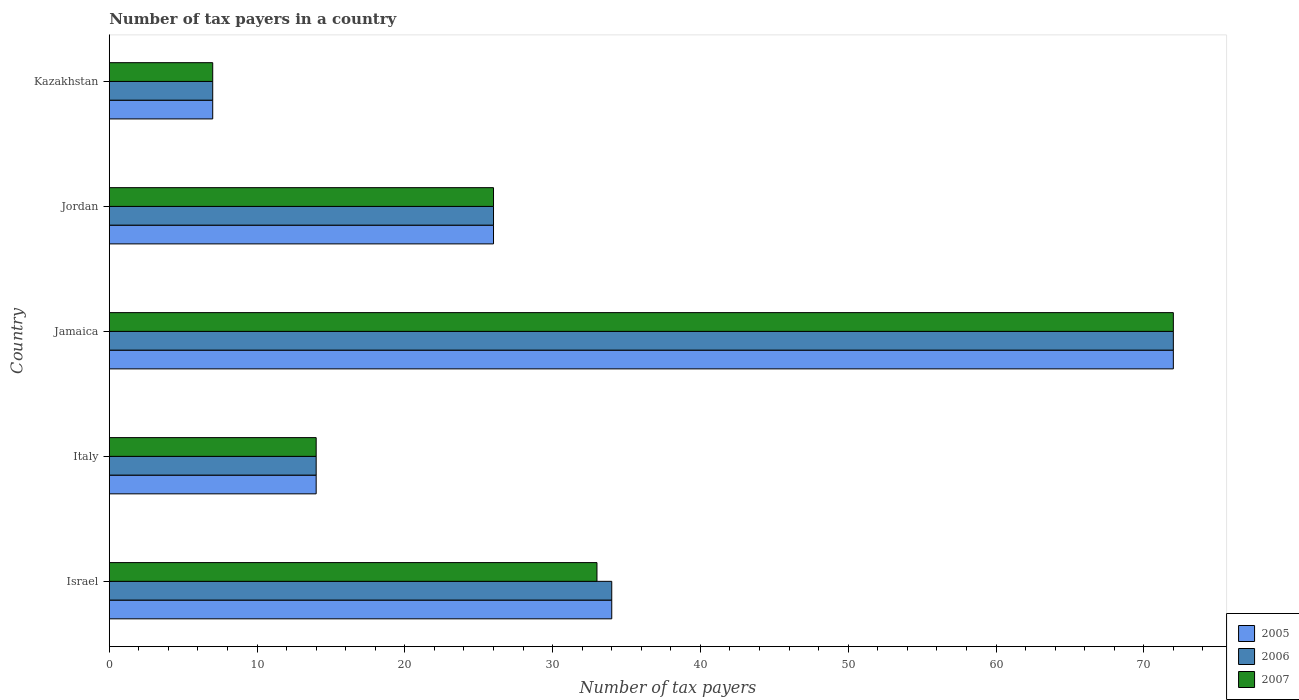Are the number of bars per tick equal to the number of legend labels?
Offer a very short reply. Yes. Are the number of bars on each tick of the Y-axis equal?
Your answer should be compact. Yes. How many bars are there on the 1st tick from the top?
Your answer should be very brief. 3. What is the label of the 2nd group of bars from the top?
Make the answer very short. Jordan. Across all countries, what is the maximum number of tax payers in in 2007?
Keep it short and to the point. 72. In which country was the number of tax payers in in 2006 maximum?
Keep it short and to the point. Jamaica. In which country was the number of tax payers in in 2007 minimum?
Ensure brevity in your answer.  Kazakhstan. What is the total number of tax payers in in 2006 in the graph?
Give a very brief answer. 153. What is the difference between the number of tax payers in in 2006 in Israel and that in Italy?
Your answer should be compact. 20. What is the difference between the number of tax payers in in 2007 in Jordan and the number of tax payers in in 2005 in Jamaica?
Your response must be concise. -46. What is the average number of tax payers in in 2006 per country?
Keep it short and to the point. 30.6. What is the ratio of the number of tax payers in in 2006 in Jamaica to that in Kazakhstan?
Your answer should be compact. 10.29. Is the number of tax payers in in 2005 in Jordan less than that in Kazakhstan?
Make the answer very short. No. What is the difference between the highest and the lowest number of tax payers in in 2006?
Provide a short and direct response. 65. In how many countries, is the number of tax payers in in 2005 greater than the average number of tax payers in in 2005 taken over all countries?
Offer a very short reply. 2. Are all the bars in the graph horizontal?
Offer a very short reply. Yes. How many countries are there in the graph?
Give a very brief answer. 5. Does the graph contain any zero values?
Your response must be concise. No. Does the graph contain grids?
Provide a short and direct response. No. Where does the legend appear in the graph?
Your answer should be very brief. Bottom right. How are the legend labels stacked?
Provide a short and direct response. Vertical. What is the title of the graph?
Ensure brevity in your answer.  Number of tax payers in a country. What is the label or title of the X-axis?
Offer a terse response. Number of tax payers. What is the label or title of the Y-axis?
Ensure brevity in your answer.  Country. What is the Number of tax payers in 2006 in Israel?
Your response must be concise. 34. What is the Number of tax payers in 2005 in Italy?
Your answer should be compact. 14. What is the Number of tax payers of 2006 in Italy?
Give a very brief answer. 14. What is the Number of tax payers in 2005 in Jamaica?
Offer a very short reply. 72. What is the Number of tax payers in 2006 in Jamaica?
Ensure brevity in your answer.  72. What is the Number of tax payers in 2007 in Jamaica?
Make the answer very short. 72. What is the Number of tax payers of 2006 in Jordan?
Make the answer very short. 26. What is the Number of tax payers in 2005 in Kazakhstan?
Your answer should be very brief. 7. What is the Number of tax payers in 2007 in Kazakhstan?
Ensure brevity in your answer.  7. Across all countries, what is the maximum Number of tax payers in 2005?
Ensure brevity in your answer.  72. Across all countries, what is the maximum Number of tax payers in 2006?
Your answer should be compact. 72. Across all countries, what is the minimum Number of tax payers in 2006?
Provide a short and direct response. 7. Across all countries, what is the minimum Number of tax payers in 2007?
Your response must be concise. 7. What is the total Number of tax payers of 2005 in the graph?
Give a very brief answer. 153. What is the total Number of tax payers of 2006 in the graph?
Provide a succinct answer. 153. What is the total Number of tax payers in 2007 in the graph?
Keep it short and to the point. 152. What is the difference between the Number of tax payers in 2005 in Israel and that in Italy?
Your answer should be compact. 20. What is the difference between the Number of tax payers in 2006 in Israel and that in Italy?
Provide a succinct answer. 20. What is the difference between the Number of tax payers in 2005 in Israel and that in Jamaica?
Keep it short and to the point. -38. What is the difference between the Number of tax payers in 2006 in Israel and that in Jamaica?
Offer a very short reply. -38. What is the difference between the Number of tax payers in 2007 in Israel and that in Jamaica?
Provide a short and direct response. -39. What is the difference between the Number of tax payers in 2005 in Israel and that in Jordan?
Your answer should be very brief. 8. What is the difference between the Number of tax payers of 2007 in Israel and that in Jordan?
Make the answer very short. 7. What is the difference between the Number of tax payers of 2005 in Israel and that in Kazakhstan?
Make the answer very short. 27. What is the difference between the Number of tax payers in 2006 in Israel and that in Kazakhstan?
Keep it short and to the point. 27. What is the difference between the Number of tax payers of 2005 in Italy and that in Jamaica?
Offer a terse response. -58. What is the difference between the Number of tax payers in 2006 in Italy and that in Jamaica?
Offer a terse response. -58. What is the difference between the Number of tax payers in 2007 in Italy and that in Jamaica?
Make the answer very short. -58. What is the difference between the Number of tax payers in 2005 in Italy and that in Jordan?
Offer a terse response. -12. What is the difference between the Number of tax payers of 2006 in Italy and that in Kazakhstan?
Make the answer very short. 7. What is the difference between the Number of tax payers of 2007 in Italy and that in Kazakhstan?
Offer a terse response. 7. What is the difference between the Number of tax payers in 2005 in Jamaica and that in Jordan?
Ensure brevity in your answer.  46. What is the difference between the Number of tax payers of 2007 in Jamaica and that in Jordan?
Ensure brevity in your answer.  46. What is the difference between the Number of tax payers in 2005 in Jamaica and that in Kazakhstan?
Your response must be concise. 65. What is the difference between the Number of tax payers of 2006 in Jamaica and that in Kazakhstan?
Provide a short and direct response. 65. What is the difference between the Number of tax payers in 2005 in Jordan and that in Kazakhstan?
Offer a terse response. 19. What is the difference between the Number of tax payers of 2006 in Jordan and that in Kazakhstan?
Give a very brief answer. 19. What is the difference between the Number of tax payers of 2005 in Israel and the Number of tax payers of 2006 in Jamaica?
Your answer should be very brief. -38. What is the difference between the Number of tax payers in 2005 in Israel and the Number of tax payers in 2007 in Jamaica?
Provide a short and direct response. -38. What is the difference between the Number of tax payers in 2006 in Israel and the Number of tax payers in 2007 in Jamaica?
Your answer should be compact. -38. What is the difference between the Number of tax payers in 2006 in Israel and the Number of tax payers in 2007 in Jordan?
Keep it short and to the point. 8. What is the difference between the Number of tax payers in 2005 in Israel and the Number of tax payers in 2006 in Kazakhstan?
Provide a short and direct response. 27. What is the difference between the Number of tax payers in 2006 in Israel and the Number of tax payers in 2007 in Kazakhstan?
Keep it short and to the point. 27. What is the difference between the Number of tax payers of 2005 in Italy and the Number of tax payers of 2006 in Jamaica?
Provide a short and direct response. -58. What is the difference between the Number of tax payers in 2005 in Italy and the Number of tax payers in 2007 in Jamaica?
Provide a short and direct response. -58. What is the difference between the Number of tax payers of 2006 in Italy and the Number of tax payers of 2007 in Jamaica?
Offer a very short reply. -58. What is the difference between the Number of tax payers of 2005 in Italy and the Number of tax payers of 2006 in Jordan?
Offer a very short reply. -12. What is the difference between the Number of tax payers of 2005 in Italy and the Number of tax payers of 2007 in Jordan?
Give a very brief answer. -12. What is the difference between the Number of tax payers of 2006 in Italy and the Number of tax payers of 2007 in Jordan?
Give a very brief answer. -12. What is the difference between the Number of tax payers in 2005 in Jamaica and the Number of tax payers in 2006 in Jordan?
Your answer should be compact. 46. What is the difference between the Number of tax payers of 2005 in Jamaica and the Number of tax payers of 2007 in Jordan?
Your answer should be compact. 46. What is the difference between the Number of tax payers of 2006 in Jamaica and the Number of tax payers of 2007 in Jordan?
Your response must be concise. 46. What is the difference between the Number of tax payers of 2005 in Jamaica and the Number of tax payers of 2006 in Kazakhstan?
Provide a succinct answer. 65. What is the difference between the Number of tax payers in 2005 in Jamaica and the Number of tax payers in 2007 in Kazakhstan?
Your response must be concise. 65. What is the difference between the Number of tax payers of 2005 in Jordan and the Number of tax payers of 2006 in Kazakhstan?
Your response must be concise. 19. What is the average Number of tax payers in 2005 per country?
Make the answer very short. 30.6. What is the average Number of tax payers of 2006 per country?
Keep it short and to the point. 30.6. What is the average Number of tax payers of 2007 per country?
Offer a terse response. 30.4. What is the difference between the Number of tax payers in 2005 and Number of tax payers in 2006 in Israel?
Provide a succinct answer. 0. What is the difference between the Number of tax payers in 2006 and Number of tax payers in 2007 in Israel?
Offer a very short reply. 1. What is the difference between the Number of tax payers in 2006 and Number of tax payers in 2007 in Italy?
Offer a terse response. 0. What is the difference between the Number of tax payers of 2005 and Number of tax payers of 2007 in Jamaica?
Provide a short and direct response. 0. What is the difference between the Number of tax payers of 2006 and Number of tax payers of 2007 in Jordan?
Your answer should be compact. 0. What is the ratio of the Number of tax payers in 2005 in Israel to that in Italy?
Give a very brief answer. 2.43. What is the ratio of the Number of tax payers of 2006 in Israel to that in Italy?
Provide a succinct answer. 2.43. What is the ratio of the Number of tax payers of 2007 in Israel to that in Italy?
Give a very brief answer. 2.36. What is the ratio of the Number of tax payers of 2005 in Israel to that in Jamaica?
Provide a short and direct response. 0.47. What is the ratio of the Number of tax payers of 2006 in Israel to that in Jamaica?
Offer a very short reply. 0.47. What is the ratio of the Number of tax payers in 2007 in Israel to that in Jamaica?
Keep it short and to the point. 0.46. What is the ratio of the Number of tax payers in 2005 in Israel to that in Jordan?
Your response must be concise. 1.31. What is the ratio of the Number of tax payers of 2006 in Israel to that in Jordan?
Offer a terse response. 1.31. What is the ratio of the Number of tax payers in 2007 in Israel to that in Jordan?
Offer a very short reply. 1.27. What is the ratio of the Number of tax payers of 2005 in Israel to that in Kazakhstan?
Your answer should be very brief. 4.86. What is the ratio of the Number of tax payers of 2006 in Israel to that in Kazakhstan?
Provide a short and direct response. 4.86. What is the ratio of the Number of tax payers of 2007 in Israel to that in Kazakhstan?
Keep it short and to the point. 4.71. What is the ratio of the Number of tax payers in 2005 in Italy to that in Jamaica?
Provide a succinct answer. 0.19. What is the ratio of the Number of tax payers in 2006 in Italy to that in Jamaica?
Provide a succinct answer. 0.19. What is the ratio of the Number of tax payers in 2007 in Italy to that in Jamaica?
Provide a succinct answer. 0.19. What is the ratio of the Number of tax payers of 2005 in Italy to that in Jordan?
Keep it short and to the point. 0.54. What is the ratio of the Number of tax payers in 2006 in Italy to that in Jordan?
Keep it short and to the point. 0.54. What is the ratio of the Number of tax payers of 2007 in Italy to that in Jordan?
Your answer should be compact. 0.54. What is the ratio of the Number of tax payers in 2006 in Italy to that in Kazakhstan?
Offer a terse response. 2. What is the ratio of the Number of tax payers of 2007 in Italy to that in Kazakhstan?
Keep it short and to the point. 2. What is the ratio of the Number of tax payers of 2005 in Jamaica to that in Jordan?
Offer a very short reply. 2.77. What is the ratio of the Number of tax payers of 2006 in Jamaica to that in Jordan?
Offer a terse response. 2.77. What is the ratio of the Number of tax payers of 2007 in Jamaica to that in Jordan?
Provide a short and direct response. 2.77. What is the ratio of the Number of tax payers of 2005 in Jamaica to that in Kazakhstan?
Offer a very short reply. 10.29. What is the ratio of the Number of tax payers of 2006 in Jamaica to that in Kazakhstan?
Provide a succinct answer. 10.29. What is the ratio of the Number of tax payers in 2007 in Jamaica to that in Kazakhstan?
Your answer should be compact. 10.29. What is the ratio of the Number of tax payers of 2005 in Jordan to that in Kazakhstan?
Provide a short and direct response. 3.71. What is the ratio of the Number of tax payers of 2006 in Jordan to that in Kazakhstan?
Make the answer very short. 3.71. What is the ratio of the Number of tax payers of 2007 in Jordan to that in Kazakhstan?
Offer a terse response. 3.71. What is the difference between the highest and the second highest Number of tax payers in 2005?
Provide a short and direct response. 38. What is the difference between the highest and the second highest Number of tax payers of 2006?
Your answer should be very brief. 38. What is the difference between the highest and the second highest Number of tax payers in 2007?
Ensure brevity in your answer.  39. What is the difference between the highest and the lowest Number of tax payers of 2005?
Provide a succinct answer. 65. 